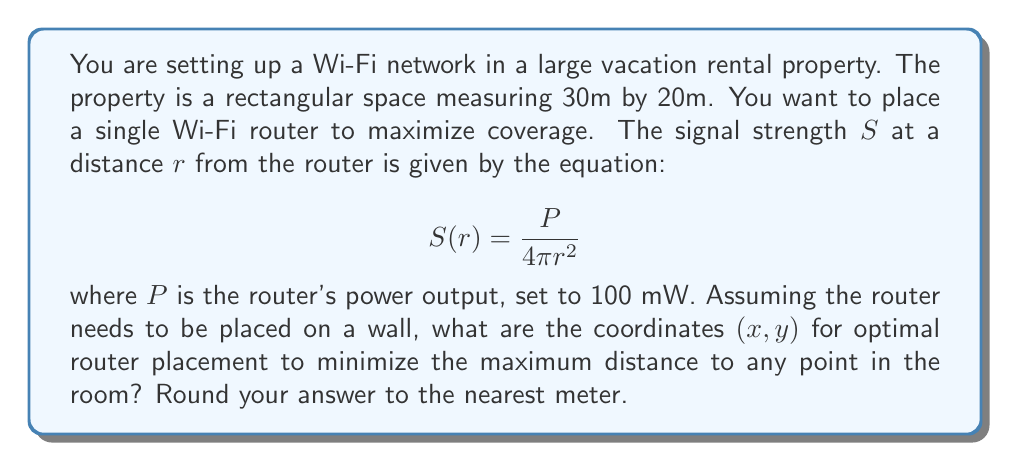Provide a solution to this math problem. To solve this problem, we need to follow these steps:

1) First, we recognize that to minimize the maximum distance to any point, the router should be placed at the center of the longest wall. This is because the farthest point will always be at a corner diagonally opposite to the router.

2) The longest walls are 30m long, so we'll place the router on one of these walls.

3) The coordinates system can be set up with (0,0) at one corner, and (30,0) at the other corner of the chosen wall.

4) The optimal x-coordinate will be at the midpoint of this wall: $x = 30/2 = 15$ m

5) The y-coordinate will be 0, as it's placed on the wall.

6) To verify, we can calculate the distance to the farthest corner:

   $$d = \sqrt{15^2 + 20^2} = \sqrt{225 + 400} = \sqrt{625} = 25$$

   This is indeed the minimum possible maximum distance.

7) We can also calculate the signal strength at this farthest point:

   $$S(25) = \frac{100}{4\pi(25)^2} \approx 0.0127 \text{ mW/m}^2$$

This placement ensures that all points in the room are at a distance of 25m or less from the router, optimizing the coverage.
Answer: The optimal router placement coordinates are (15, 0) meters. 